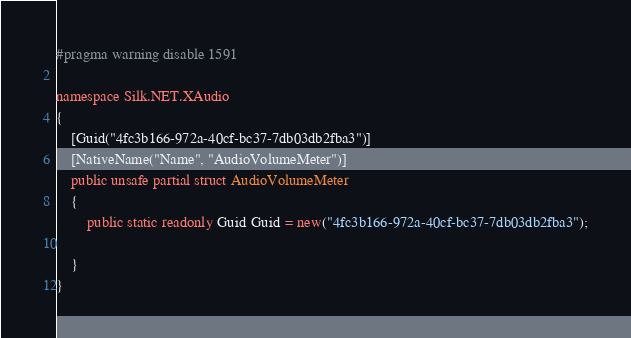<code> <loc_0><loc_0><loc_500><loc_500><_C#_>#pragma warning disable 1591

namespace Silk.NET.XAudio
{
    [Guid("4fc3b166-972a-40cf-bc37-7db03db2fba3")]
    [NativeName("Name", "AudioVolumeMeter")]
    public unsafe partial struct AudioVolumeMeter
    {
        public static readonly Guid Guid = new("4fc3b166-972a-40cf-bc37-7db03db2fba3");

    }
}
</code> 